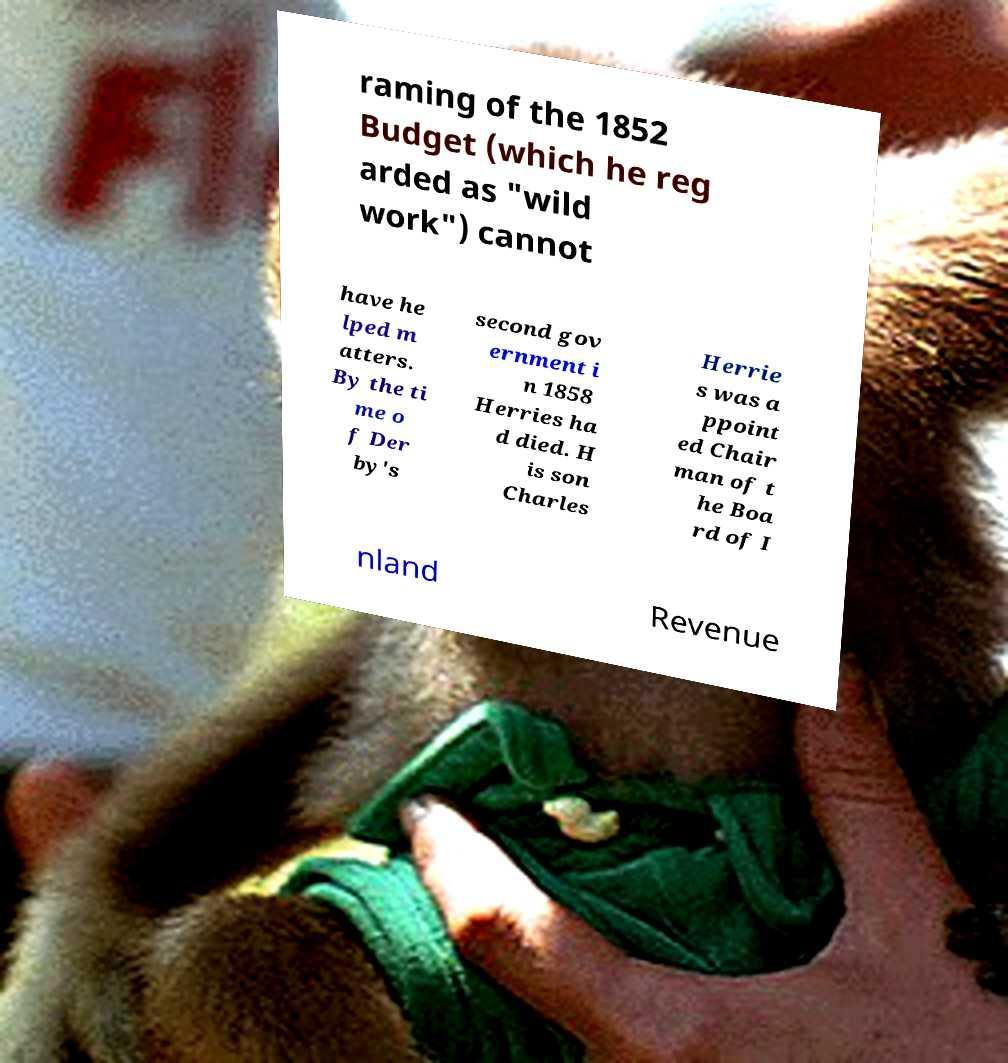Can you read and provide the text displayed in the image?This photo seems to have some interesting text. Can you extract and type it out for me? raming of the 1852 Budget (which he reg arded as "wild work") cannot have he lped m atters. By the ti me o f Der by's second gov ernment i n 1858 Herries ha d died. H is son Charles Herrie s was a ppoint ed Chair man of t he Boa rd of I nland Revenue 